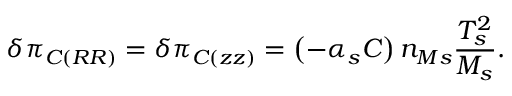<formula> <loc_0><loc_0><loc_500><loc_500>\delta \pi _ { C \left ( R R \right ) } = \delta \pi _ { C \left ( z z \right ) } = \left ( - \alpha _ { s } C \right ) n _ { M s } \frac { T _ { s } ^ { 2 } } { M _ { s } } .</formula> 